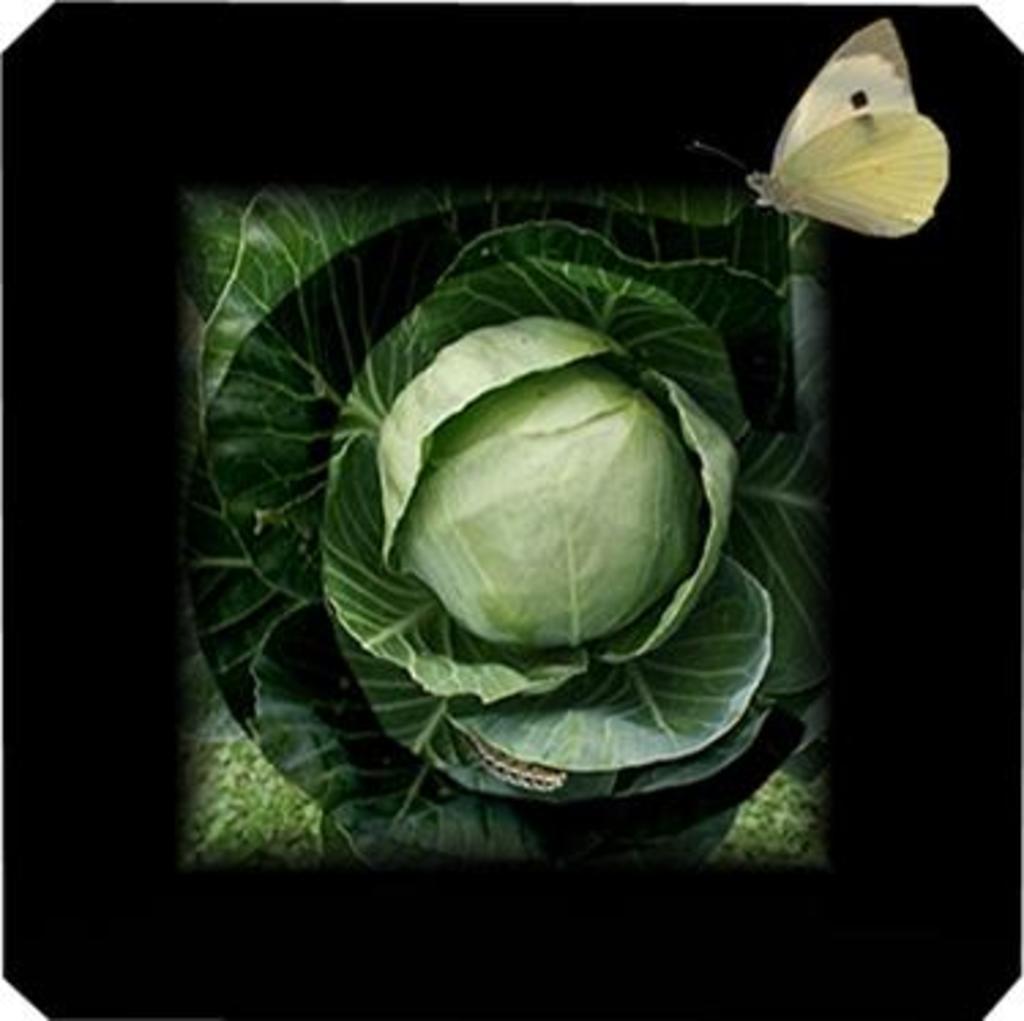In one or two sentences, can you explain what this image depicts? In this image in the center there is cabbage and some leaves, and the foreground is dark and there is one butterfly. 